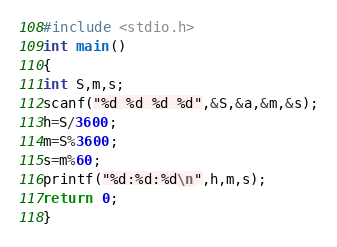Convert code to text. <code><loc_0><loc_0><loc_500><loc_500><_C++_>#include <stdio.h>
int main()
{
int S,m,s;
scanf("%d %d %d %d",&S,&a,&m,&s);
h=S/3600;
m=S%3600;
s=m%60;
printf("%d:%d:%d\n",h,m,s);
return 0;
}</code> 